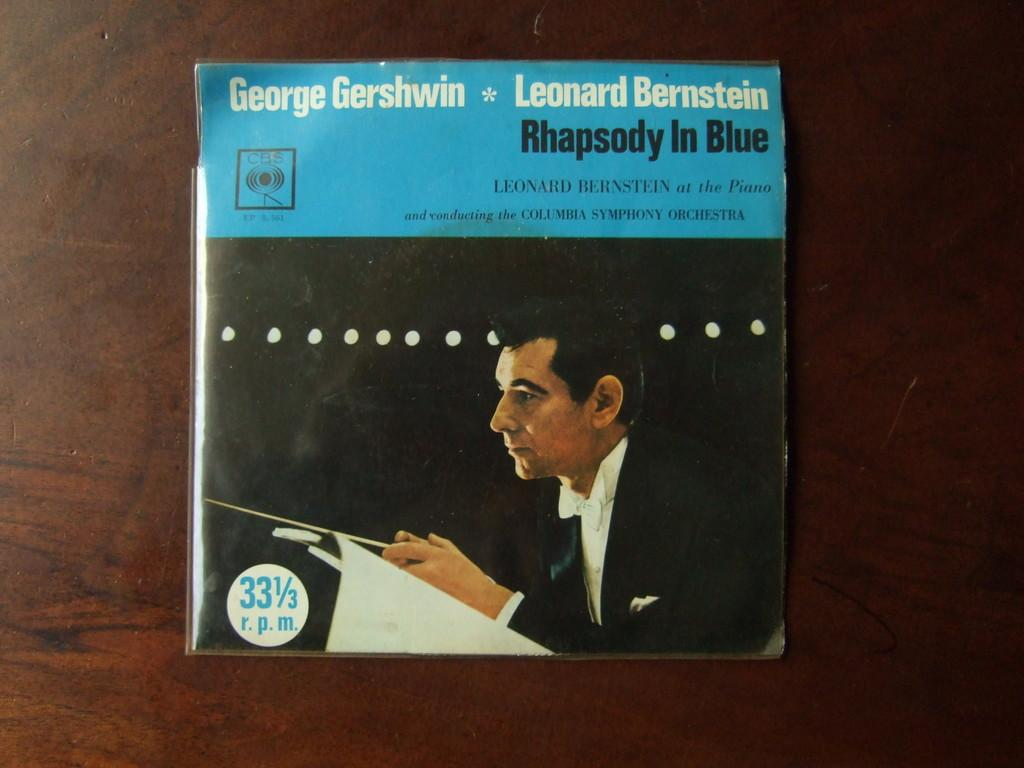What piece of furniture is present in the image? There is a table in the image. Is there anything placed on the table? Yes, there is an object on the table. Can you see the person cooking on the table in the image? There is no person or cooking activity depicted in the image. 